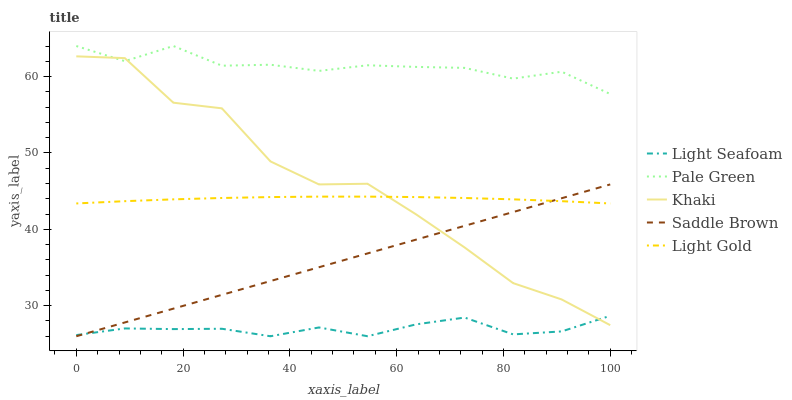Does Light Seafoam have the minimum area under the curve?
Answer yes or no. Yes. Does Pale Green have the maximum area under the curve?
Answer yes or no. Yes. Does Light Gold have the minimum area under the curve?
Answer yes or no. No. Does Light Gold have the maximum area under the curve?
Answer yes or no. No. Is Saddle Brown the smoothest?
Answer yes or no. Yes. Is Khaki the roughest?
Answer yes or no. Yes. Is Light Seafoam the smoothest?
Answer yes or no. No. Is Light Seafoam the roughest?
Answer yes or no. No. Does Light Seafoam have the lowest value?
Answer yes or no. Yes. Does Light Gold have the lowest value?
Answer yes or no. No. Does Pale Green have the highest value?
Answer yes or no. Yes. Does Light Gold have the highest value?
Answer yes or no. No. Is Light Seafoam less than Light Gold?
Answer yes or no. Yes. Is Pale Green greater than Light Gold?
Answer yes or no. Yes. Does Light Gold intersect Khaki?
Answer yes or no. Yes. Is Light Gold less than Khaki?
Answer yes or no. No. Is Light Gold greater than Khaki?
Answer yes or no. No. Does Light Seafoam intersect Light Gold?
Answer yes or no. No. 